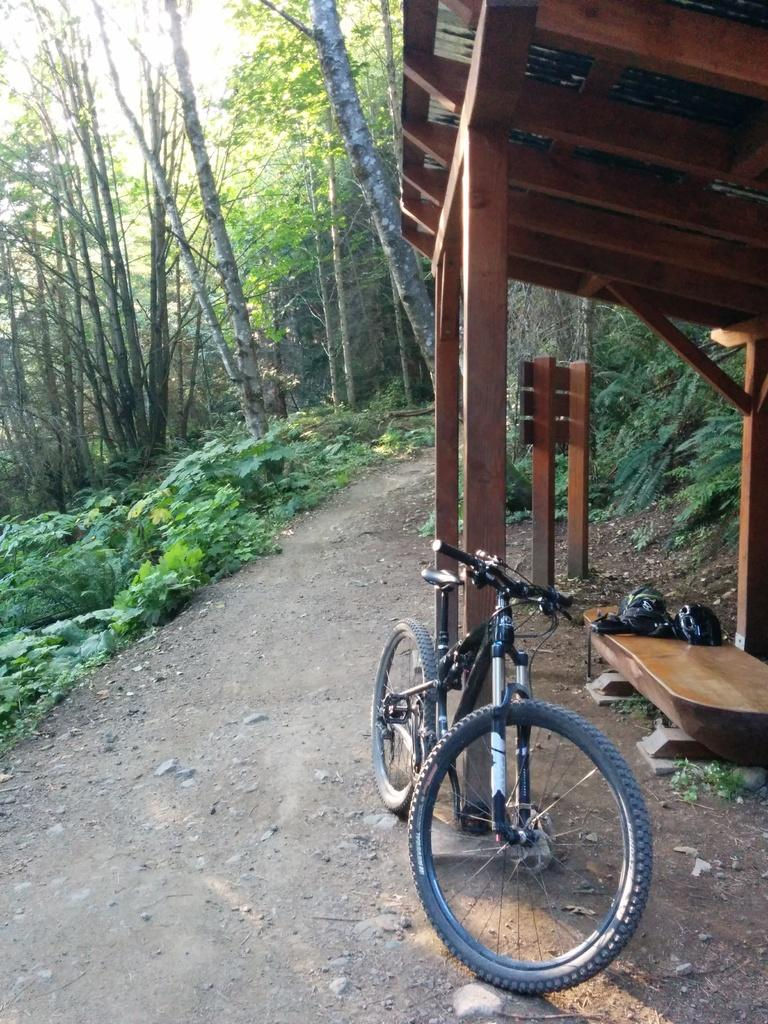What is the main object in the image? There is a bicycle in the image. What can be seen in the background of the image? There is a shed, a path, grass, and trees visible in the background of the image. Can you see a kitten biting the bicycle tire in the image? No, there is no kitten or any indication of a bite on the bicycle tire in the image. 